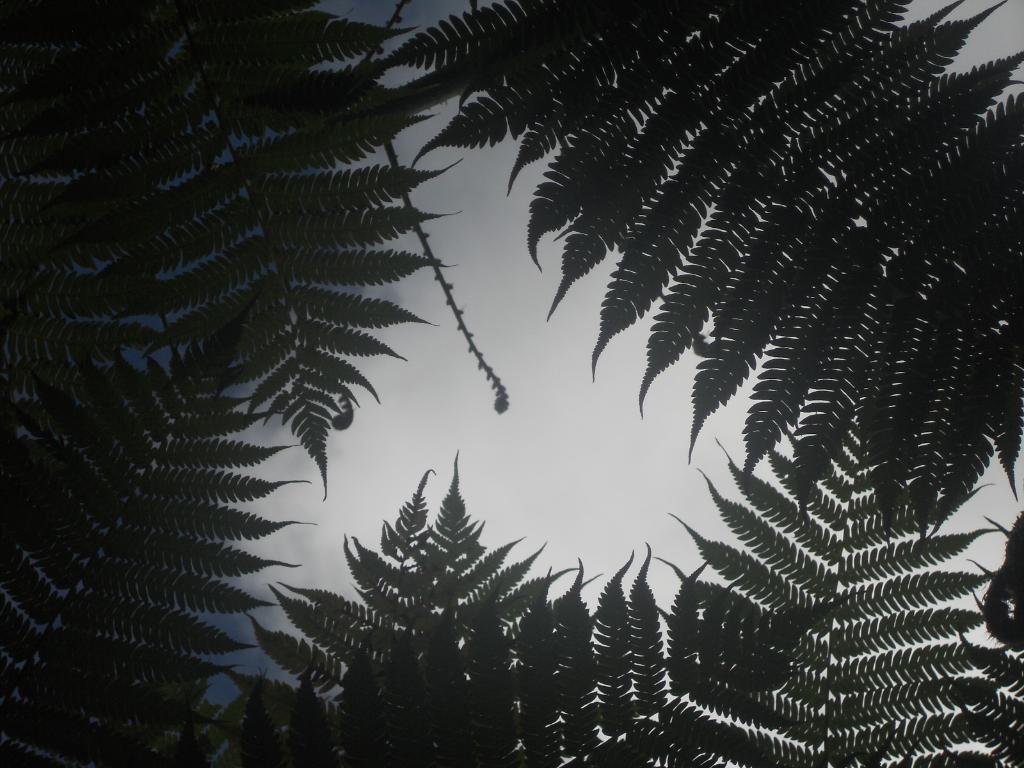How would you summarize this image in a sentence or two? In this picture there are few leaves of a tree and the sky is cloudy. 